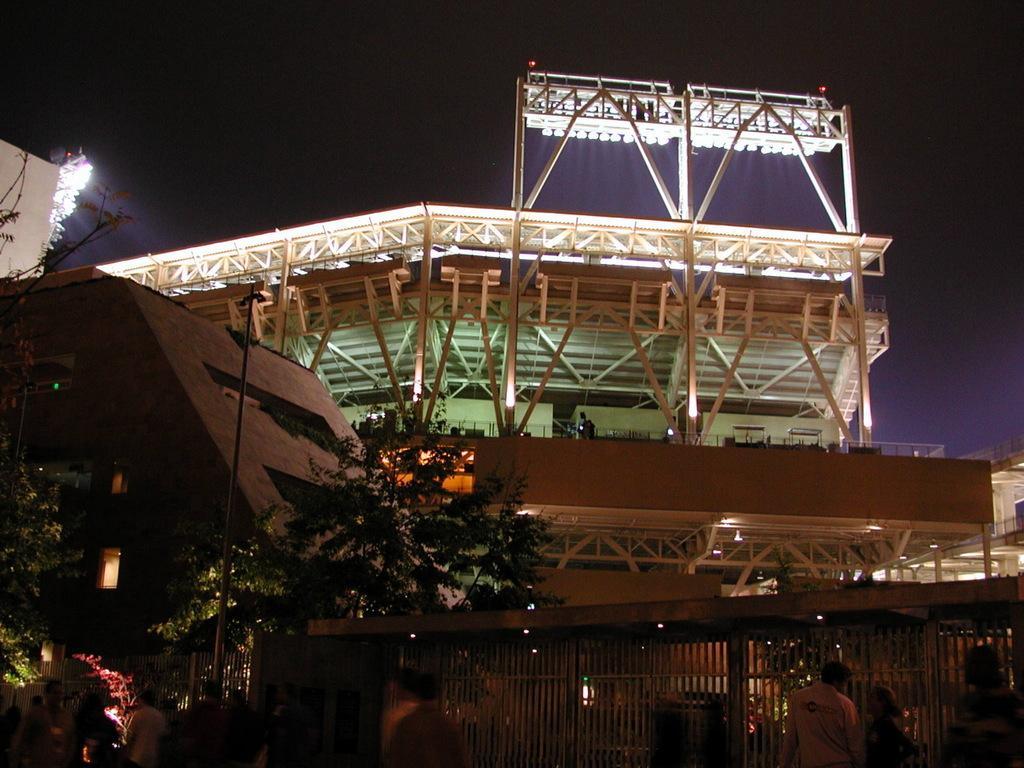Could you give a brief overview of what you see in this image? In the picture I can see building, top of the roof some lights are arranged, in front of the building we can see trees, some people are walking side of the fence. 